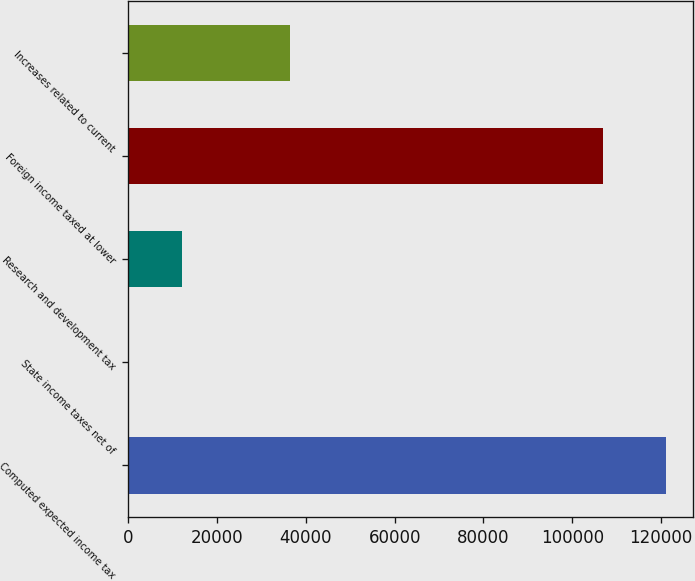Convert chart to OTSL. <chart><loc_0><loc_0><loc_500><loc_500><bar_chart><fcel>Computed expected income tax<fcel>State income taxes net of<fcel>Research and development tax<fcel>Foreign income taxed at lower<fcel>Increases related to current<nl><fcel>121067<fcel>20<fcel>12124.7<fcel>106939<fcel>36334.1<nl></chart> 